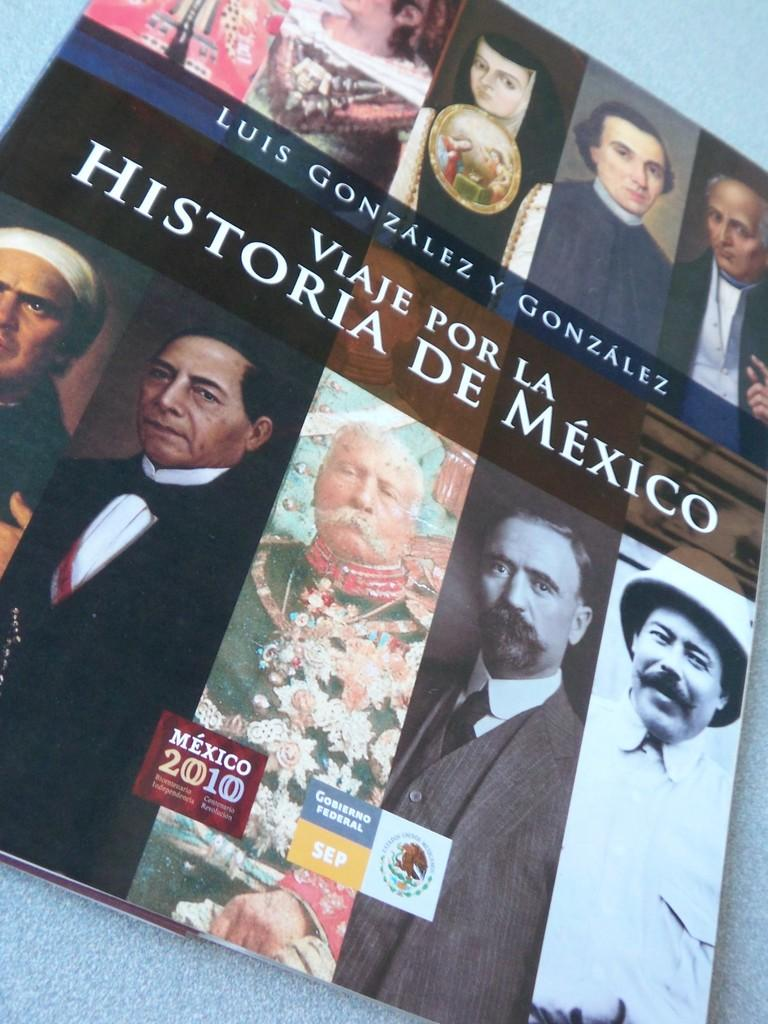What type of page is shown in the image? The image is a cover page of a book. What can be seen on the cover page besides text? There are images of persons on the cover page. What information is provided on the cover page? There is text on the cover page. Can you tell me how many cats are depicted on the cover page? There are no cats depicted on the cover page; it features images of persons and text. What type of memory is being triggered by the cover page? The cover page does not trigger any specific memory, as it is a visual representation of a book's cover. 